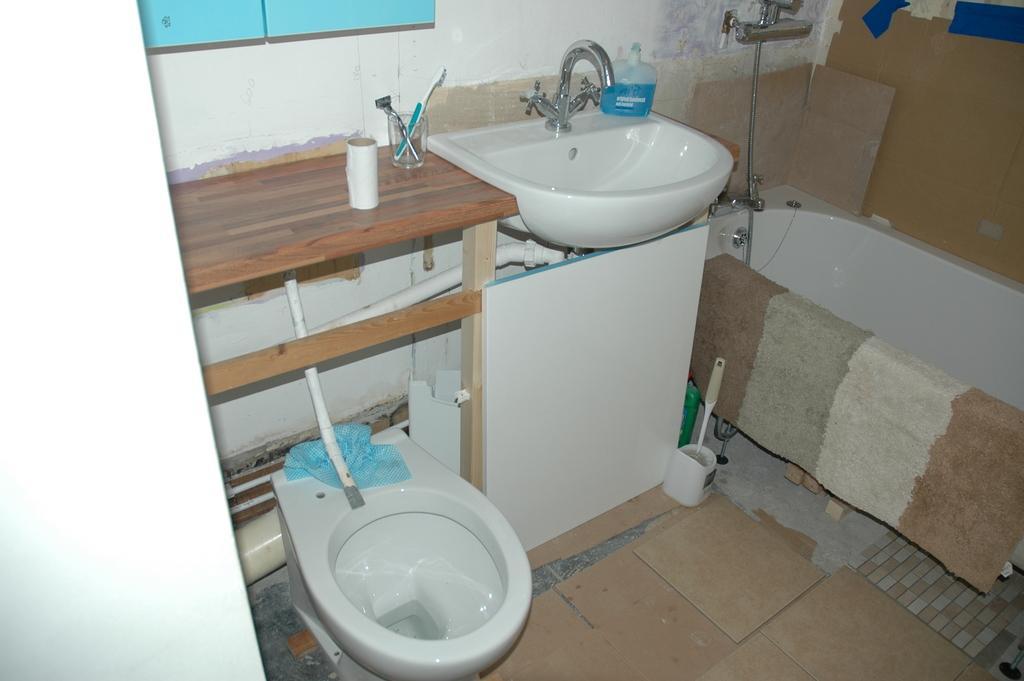Please provide a concise description of this image. This is a picture of an washroom. On the left there is a door, a basin and a desk, on the desk there are brush, razor and a tissue. In the center of the picture there is a sink, a tap and hand wash. On the right there is a bathtub and pipe. 